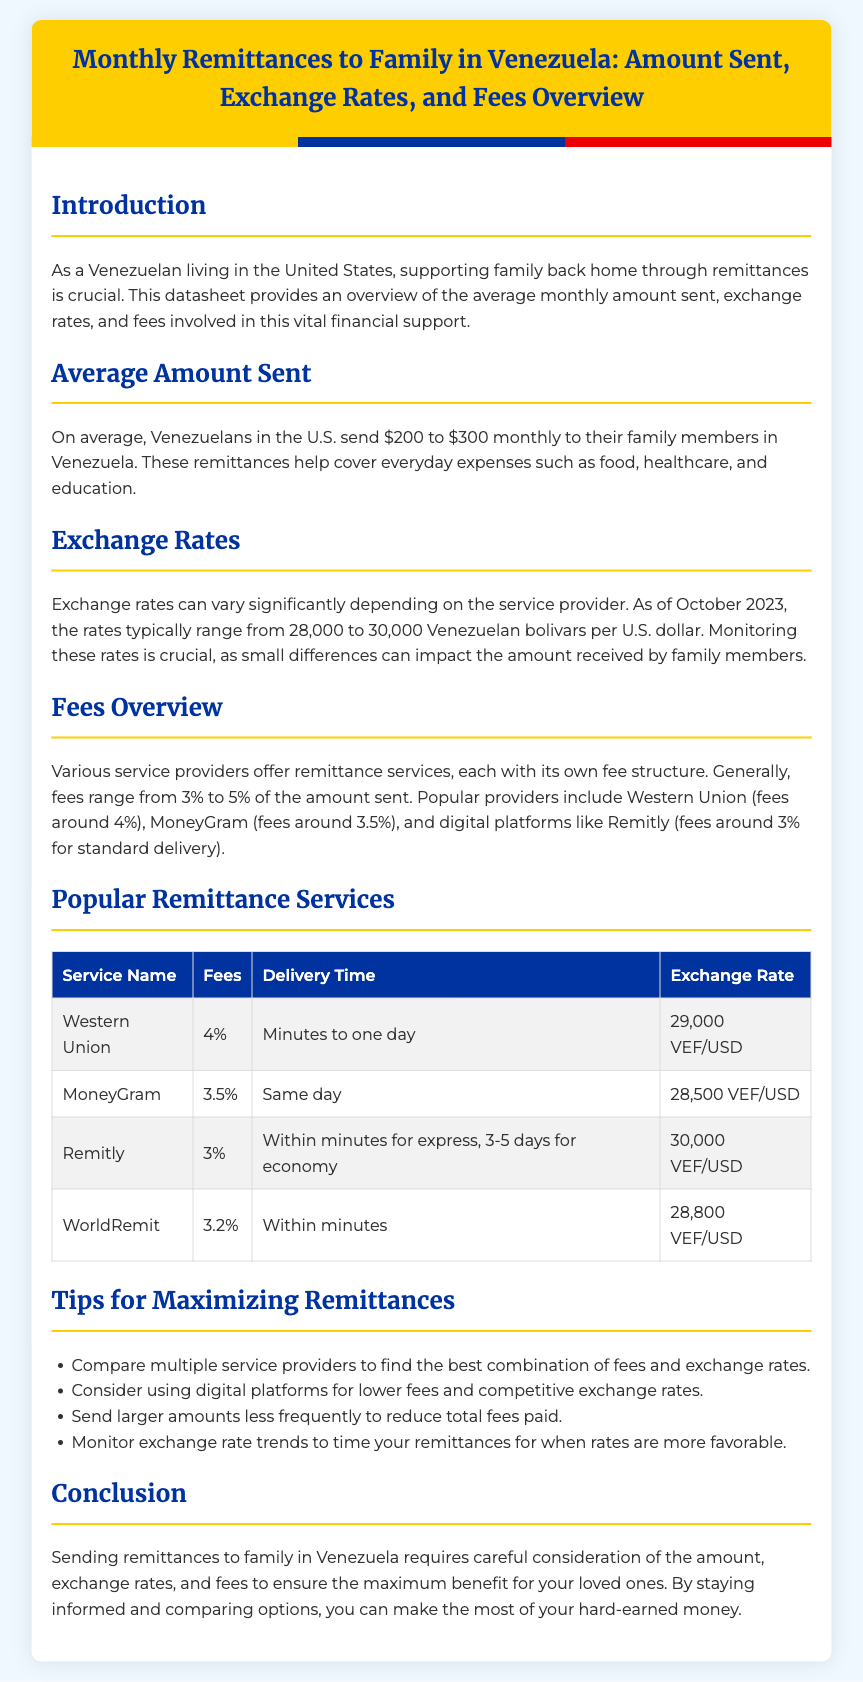what is the average amount sent monthly? The average amount sent monthly by Venezuelans in the U.S. ranges from $200 to $300.
Answer: $200 to $300 what are the exchange rates as of October 2023? The exchange rates for remittances to Venezuela vary from 28,000 to 30,000 Venezuelan bolivars per U.S. dollar.
Answer: 28,000 to 30,000 VEF/USD what is the fee percentage for Remitly? The fees for Remitly are typically around 3% of the amount sent.
Answer: 3% which service has the lowest fees? Among the listed services, Remitly has the lowest fees at 3%.
Answer: Remitly how long does it take for MoneyGram to deliver remittances? MoneyGram delivers remittances the same day.
Answer: Same day what is one tip for maximizing remittances? One tip to maximize remittances is to compare multiple service providers for better options.
Answer: Compare multiple providers what is the delivery time for Western Union? Western Union has a delivery time ranging from minutes to one day.
Answer: Minutes to one day how much is the fee for WorldRemit? The fees for WorldRemit are approximately 3.2%.
Answer: 3.2% 